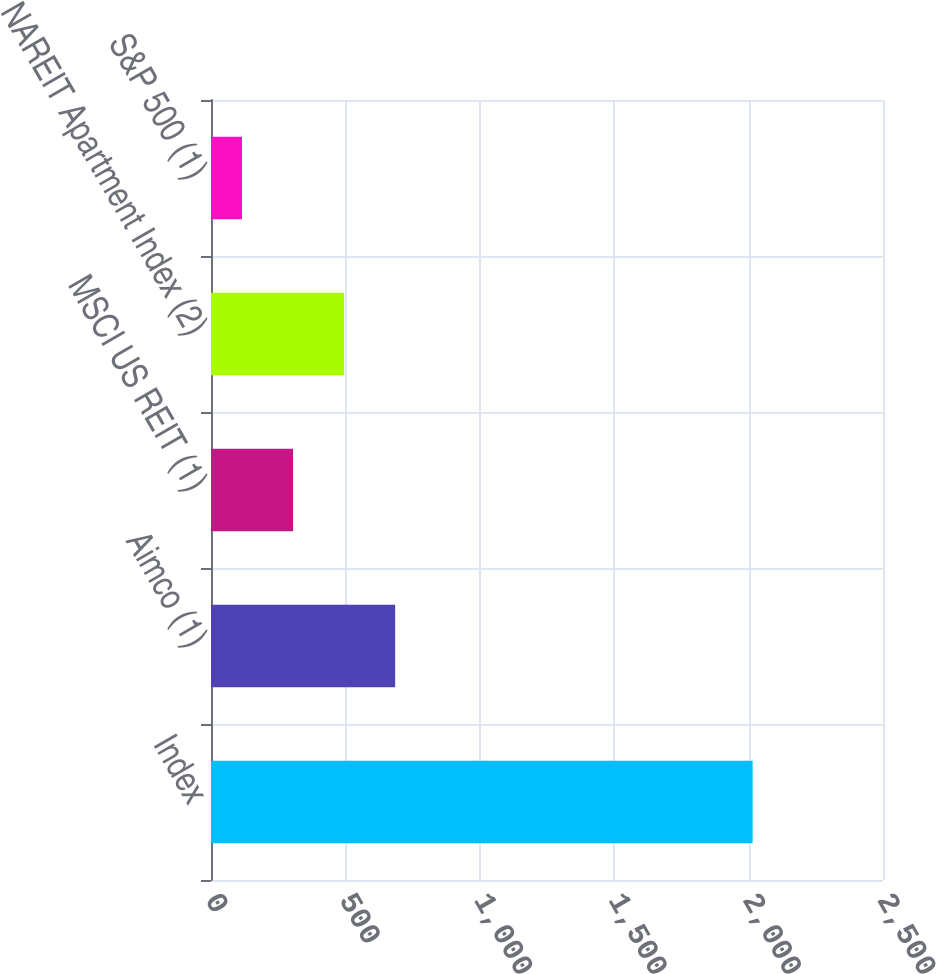Convert chart. <chart><loc_0><loc_0><loc_500><loc_500><bar_chart><fcel>Index<fcel>Aimco (1)<fcel>MSCI US REIT (1)<fcel>NAREIT Apartment Index (2)<fcel>S&P 500 (1)<nl><fcel>2015<fcel>685.17<fcel>305.23<fcel>495.2<fcel>115.26<nl></chart> 